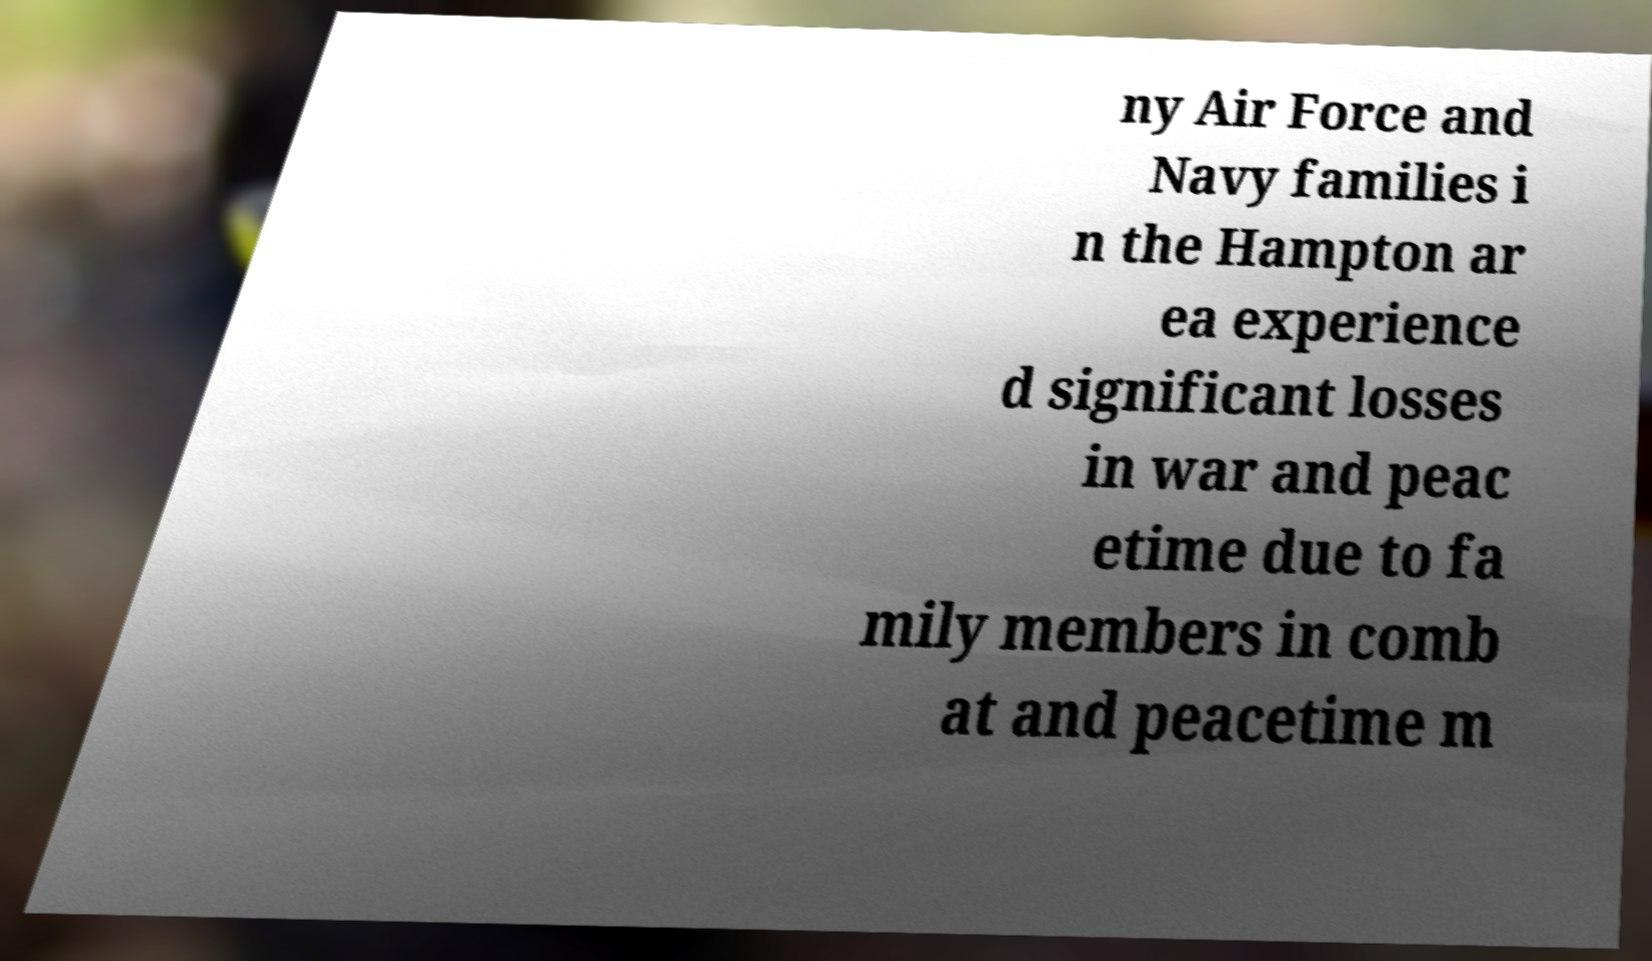Please read and relay the text visible in this image. What does it say? ny Air Force and Navy families i n the Hampton ar ea experience d significant losses in war and peac etime due to fa mily members in comb at and peacetime m 